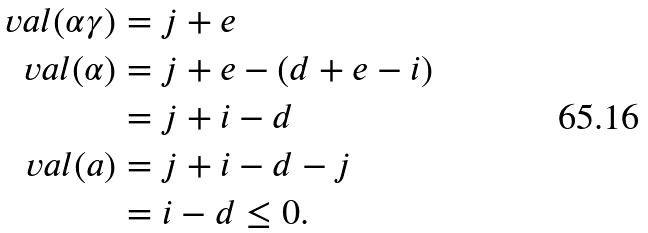<formula> <loc_0><loc_0><loc_500><loc_500>\ v a l ( \alpha \gamma ) & = j + e \\ \ v a l ( \alpha ) & = j + e - ( d + e - i ) \\ & = j + i - d \\ \ v a l ( a ) & = j + i - d - j \\ & = i - d \leq 0 .</formula> 